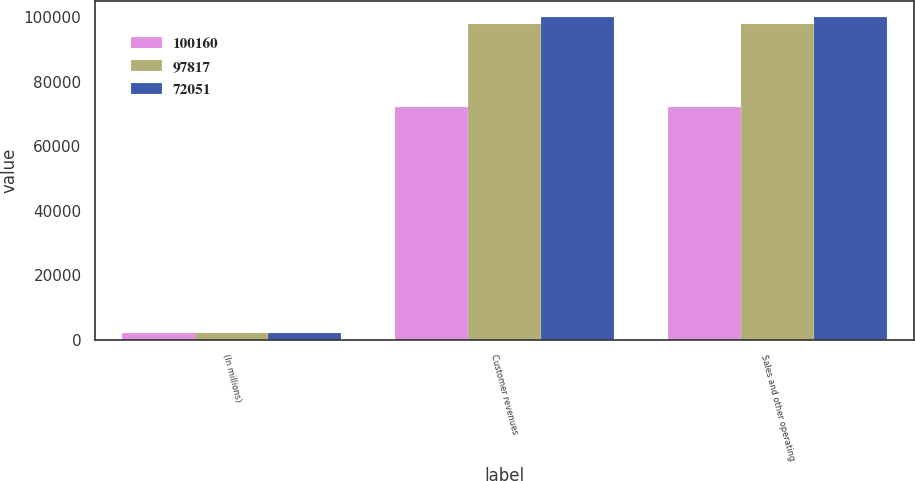<chart> <loc_0><loc_0><loc_500><loc_500><stacked_bar_chart><ecel><fcel>(In millions)<fcel>Customer revenues<fcel>Sales and other operating<nl><fcel>100160<fcel>2015<fcel>72051<fcel>72051<nl><fcel>97817<fcel>2014<fcel>97819<fcel>97817<nl><fcel>72051<fcel>2013<fcel>100166<fcel>100160<nl></chart> 